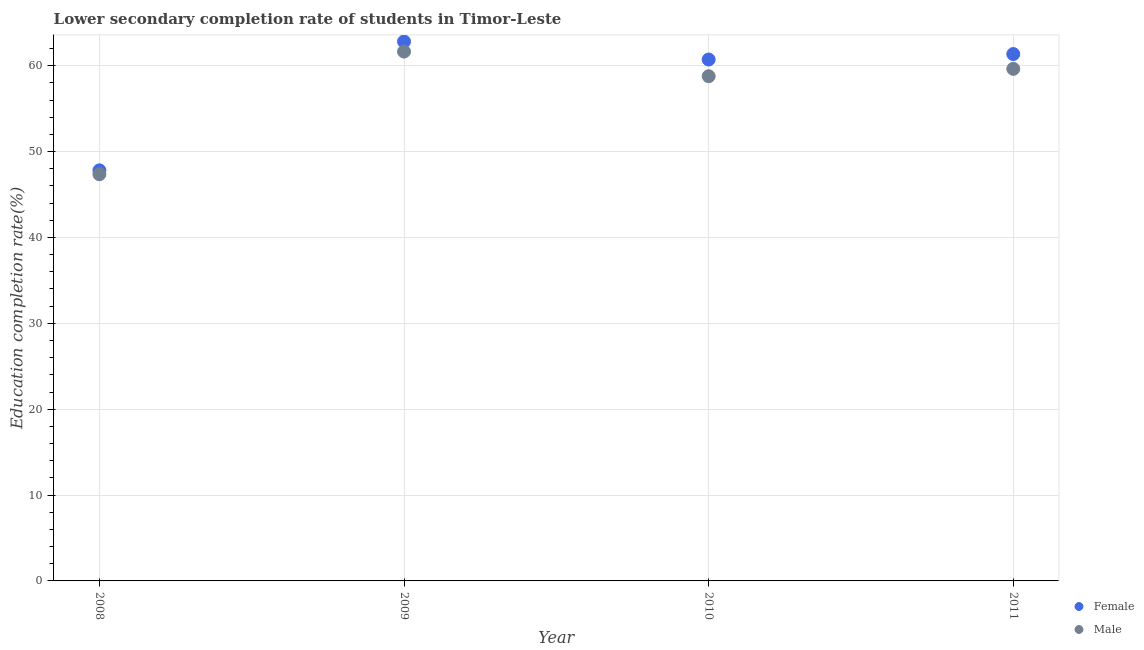How many different coloured dotlines are there?
Keep it short and to the point. 2. Is the number of dotlines equal to the number of legend labels?
Give a very brief answer. Yes. What is the education completion rate of male students in 2009?
Keep it short and to the point. 61.64. Across all years, what is the maximum education completion rate of male students?
Offer a terse response. 61.64. Across all years, what is the minimum education completion rate of female students?
Your answer should be compact. 47.81. What is the total education completion rate of male students in the graph?
Your answer should be compact. 227.41. What is the difference between the education completion rate of female students in 2008 and that in 2009?
Keep it short and to the point. -15. What is the difference between the education completion rate of female students in 2008 and the education completion rate of male students in 2009?
Your answer should be compact. -13.83. What is the average education completion rate of male students per year?
Your response must be concise. 56.85. In the year 2009, what is the difference between the education completion rate of male students and education completion rate of female students?
Make the answer very short. -1.17. In how many years, is the education completion rate of male students greater than 42 %?
Keep it short and to the point. 4. What is the ratio of the education completion rate of female students in 2009 to that in 2011?
Offer a very short reply. 1.02. Is the education completion rate of female students in 2008 less than that in 2010?
Offer a very short reply. Yes. Is the difference between the education completion rate of male students in 2009 and 2010 greater than the difference between the education completion rate of female students in 2009 and 2010?
Your answer should be compact. Yes. What is the difference between the highest and the second highest education completion rate of female students?
Make the answer very short. 1.46. What is the difference between the highest and the lowest education completion rate of male students?
Make the answer very short. 14.28. Is the sum of the education completion rate of male students in 2008 and 2009 greater than the maximum education completion rate of female students across all years?
Make the answer very short. Yes. How many dotlines are there?
Offer a very short reply. 2. How many years are there in the graph?
Make the answer very short. 4. What is the difference between two consecutive major ticks on the Y-axis?
Offer a very short reply. 10. Does the graph contain any zero values?
Give a very brief answer. No. Does the graph contain grids?
Your answer should be compact. Yes. Where does the legend appear in the graph?
Offer a terse response. Bottom right. How many legend labels are there?
Your answer should be very brief. 2. How are the legend labels stacked?
Your answer should be compact. Vertical. What is the title of the graph?
Your answer should be very brief. Lower secondary completion rate of students in Timor-Leste. What is the label or title of the Y-axis?
Your answer should be very brief. Education completion rate(%). What is the Education completion rate(%) of Female in 2008?
Provide a short and direct response. 47.81. What is the Education completion rate(%) of Male in 2008?
Keep it short and to the point. 47.36. What is the Education completion rate(%) of Female in 2009?
Offer a terse response. 62.82. What is the Education completion rate(%) of Male in 2009?
Give a very brief answer. 61.64. What is the Education completion rate(%) of Female in 2010?
Offer a very short reply. 60.72. What is the Education completion rate(%) of Male in 2010?
Your response must be concise. 58.77. What is the Education completion rate(%) in Female in 2011?
Ensure brevity in your answer.  61.35. What is the Education completion rate(%) of Male in 2011?
Ensure brevity in your answer.  59.63. Across all years, what is the maximum Education completion rate(%) of Female?
Provide a short and direct response. 62.82. Across all years, what is the maximum Education completion rate(%) in Male?
Offer a terse response. 61.64. Across all years, what is the minimum Education completion rate(%) in Female?
Your answer should be very brief. 47.81. Across all years, what is the minimum Education completion rate(%) of Male?
Ensure brevity in your answer.  47.36. What is the total Education completion rate(%) in Female in the graph?
Give a very brief answer. 232.7. What is the total Education completion rate(%) of Male in the graph?
Offer a terse response. 227.41. What is the difference between the Education completion rate(%) of Female in 2008 and that in 2009?
Your answer should be very brief. -15. What is the difference between the Education completion rate(%) in Male in 2008 and that in 2009?
Provide a short and direct response. -14.28. What is the difference between the Education completion rate(%) in Female in 2008 and that in 2010?
Your answer should be compact. -12.91. What is the difference between the Education completion rate(%) in Male in 2008 and that in 2010?
Ensure brevity in your answer.  -11.41. What is the difference between the Education completion rate(%) of Female in 2008 and that in 2011?
Provide a succinct answer. -13.54. What is the difference between the Education completion rate(%) of Male in 2008 and that in 2011?
Your response must be concise. -12.27. What is the difference between the Education completion rate(%) of Female in 2009 and that in 2010?
Offer a very short reply. 2.1. What is the difference between the Education completion rate(%) of Male in 2009 and that in 2010?
Make the answer very short. 2.87. What is the difference between the Education completion rate(%) of Female in 2009 and that in 2011?
Provide a succinct answer. 1.46. What is the difference between the Education completion rate(%) of Male in 2009 and that in 2011?
Offer a very short reply. 2.01. What is the difference between the Education completion rate(%) of Female in 2010 and that in 2011?
Give a very brief answer. -0.64. What is the difference between the Education completion rate(%) in Male in 2010 and that in 2011?
Your answer should be compact. -0.86. What is the difference between the Education completion rate(%) in Female in 2008 and the Education completion rate(%) in Male in 2009?
Your answer should be very brief. -13.83. What is the difference between the Education completion rate(%) in Female in 2008 and the Education completion rate(%) in Male in 2010?
Ensure brevity in your answer.  -10.96. What is the difference between the Education completion rate(%) of Female in 2008 and the Education completion rate(%) of Male in 2011?
Your response must be concise. -11.82. What is the difference between the Education completion rate(%) of Female in 2009 and the Education completion rate(%) of Male in 2010?
Your answer should be compact. 4.04. What is the difference between the Education completion rate(%) of Female in 2009 and the Education completion rate(%) of Male in 2011?
Your answer should be compact. 3.18. What is the difference between the Education completion rate(%) of Female in 2010 and the Education completion rate(%) of Male in 2011?
Provide a succinct answer. 1.09. What is the average Education completion rate(%) of Female per year?
Ensure brevity in your answer.  58.17. What is the average Education completion rate(%) in Male per year?
Provide a short and direct response. 56.85. In the year 2008, what is the difference between the Education completion rate(%) in Female and Education completion rate(%) in Male?
Ensure brevity in your answer.  0.45. In the year 2009, what is the difference between the Education completion rate(%) of Female and Education completion rate(%) of Male?
Offer a terse response. 1.17. In the year 2010, what is the difference between the Education completion rate(%) in Female and Education completion rate(%) in Male?
Offer a terse response. 1.94. In the year 2011, what is the difference between the Education completion rate(%) of Female and Education completion rate(%) of Male?
Keep it short and to the point. 1.72. What is the ratio of the Education completion rate(%) in Female in 2008 to that in 2009?
Give a very brief answer. 0.76. What is the ratio of the Education completion rate(%) of Male in 2008 to that in 2009?
Your response must be concise. 0.77. What is the ratio of the Education completion rate(%) in Female in 2008 to that in 2010?
Your answer should be very brief. 0.79. What is the ratio of the Education completion rate(%) in Male in 2008 to that in 2010?
Offer a very short reply. 0.81. What is the ratio of the Education completion rate(%) in Female in 2008 to that in 2011?
Offer a very short reply. 0.78. What is the ratio of the Education completion rate(%) in Male in 2008 to that in 2011?
Give a very brief answer. 0.79. What is the ratio of the Education completion rate(%) of Female in 2009 to that in 2010?
Provide a succinct answer. 1.03. What is the ratio of the Education completion rate(%) of Male in 2009 to that in 2010?
Your answer should be compact. 1.05. What is the ratio of the Education completion rate(%) of Female in 2009 to that in 2011?
Your answer should be compact. 1.02. What is the ratio of the Education completion rate(%) of Male in 2009 to that in 2011?
Provide a short and direct response. 1.03. What is the ratio of the Education completion rate(%) of Female in 2010 to that in 2011?
Keep it short and to the point. 0.99. What is the ratio of the Education completion rate(%) in Male in 2010 to that in 2011?
Offer a very short reply. 0.99. What is the difference between the highest and the second highest Education completion rate(%) of Female?
Provide a short and direct response. 1.46. What is the difference between the highest and the second highest Education completion rate(%) of Male?
Your response must be concise. 2.01. What is the difference between the highest and the lowest Education completion rate(%) of Female?
Provide a short and direct response. 15. What is the difference between the highest and the lowest Education completion rate(%) of Male?
Ensure brevity in your answer.  14.28. 